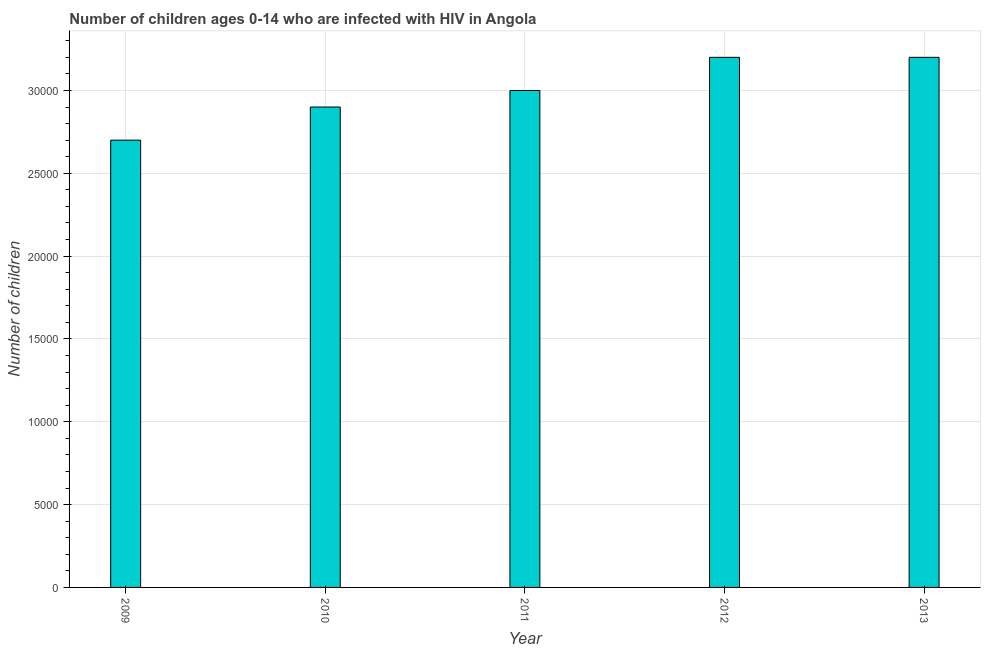Does the graph contain any zero values?
Provide a succinct answer. No. What is the title of the graph?
Ensure brevity in your answer.  Number of children ages 0-14 who are infected with HIV in Angola. What is the label or title of the Y-axis?
Offer a terse response. Number of children. What is the number of children living with hiv in 2012?
Keep it short and to the point. 3.20e+04. Across all years, what is the maximum number of children living with hiv?
Make the answer very short. 3.20e+04. Across all years, what is the minimum number of children living with hiv?
Your answer should be very brief. 2.70e+04. In which year was the number of children living with hiv minimum?
Your response must be concise. 2009. What is the sum of the number of children living with hiv?
Provide a short and direct response. 1.50e+05. What is the difference between the number of children living with hiv in 2010 and 2011?
Ensure brevity in your answer.  -1000. What is the difference between the highest and the lowest number of children living with hiv?
Your response must be concise. 5000. In how many years, is the number of children living with hiv greater than the average number of children living with hiv taken over all years?
Make the answer very short. 2. How many bars are there?
Ensure brevity in your answer.  5. Are all the bars in the graph horizontal?
Your answer should be compact. No. What is the Number of children in 2009?
Your answer should be compact. 2.70e+04. What is the Number of children of 2010?
Provide a succinct answer. 2.90e+04. What is the Number of children in 2011?
Ensure brevity in your answer.  3.00e+04. What is the Number of children in 2012?
Ensure brevity in your answer.  3.20e+04. What is the Number of children in 2013?
Provide a short and direct response. 3.20e+04. What is the difference between the Number of children in 2009 and 2010?
Give a very brief answer. -2000. What is the difference between the Number of children in 2009 and 2011?
Give a very brief answer. -3000. What is the difference between the Number of children in 2009 and 2012?
Your answer should be very brief. -5000. What is the difference between the Number of children in 2009 and 2013?
Ensure brevity in your answer.  -5000. What is the difference between the Number of children in 2010 and 2011?
Keep it short and to the point. -1000. What is the difference between the Number of children in 2010 and 2012?
Make the answer very short. -3000. What is the difference between the Number of children in 2010 and 2013?
Give a very brief answer. -3000. What is the difference between the Number of children in 2011 and 2012?
Your answer should be very brief. -2000. What is the difference between the Number of children in 2011 and 2013?
Provide a short and direct response. -2000. What is the ratio of the Number of children in 2009 to that in 2012?
Your response must be concise. 0.84. What is the ratio of the Number of children in 2009 to that in 2013?
Your answer should be very brief. 0.84. What is the ratio of the Number of children in 2010 to that in 2012?
Provide a succinct answer. 0.91. What is the ratio of the Number of children in 2010 to that in 2013?
Give a very brief answer. 0.91. What is the ratio of the Number of children in 2011 to that in 2012?
Provide a short and direct response. 0.94. What is the ratio of the Number of children in 2011 to that in 2013?
Offer a terse response. 0.94. 